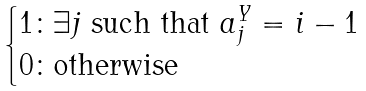Convert formula to latex. <formula><loc_0><loc_0><loc_500><loc_500>\begin{cases} 1 \colon \exists j \text { such that } a ^ { Y } _ { j } = i - 1 \\ 0 \colon \text {otherwise} \end{cases}</formula> 